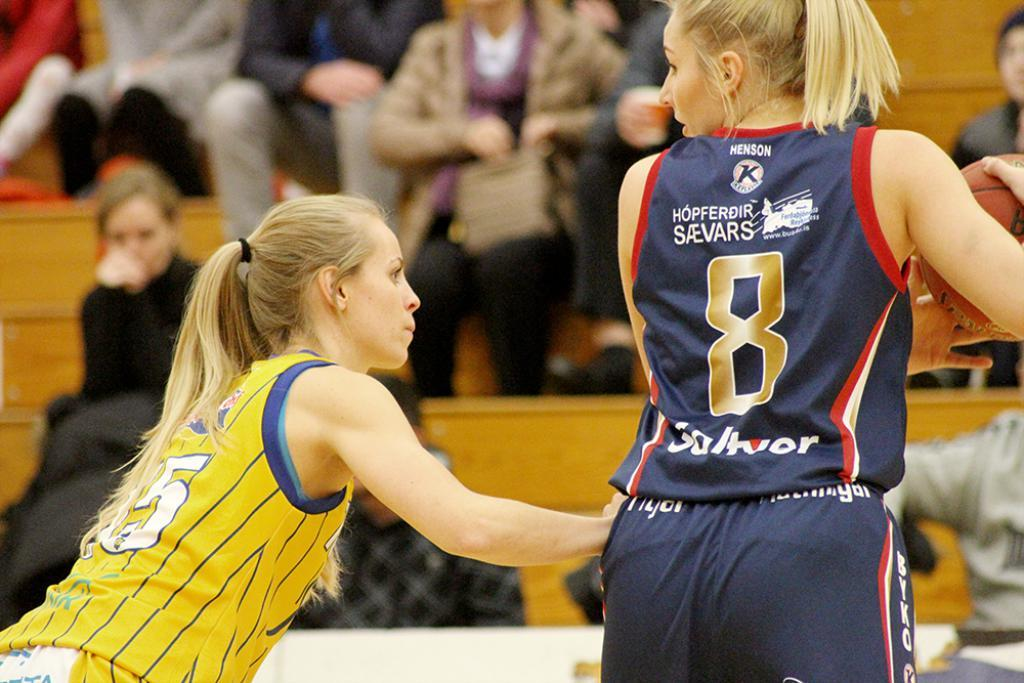<image>
Share a concise interpretation of the image provided. A female basketball player, wearing the number 8, handles the ball. 